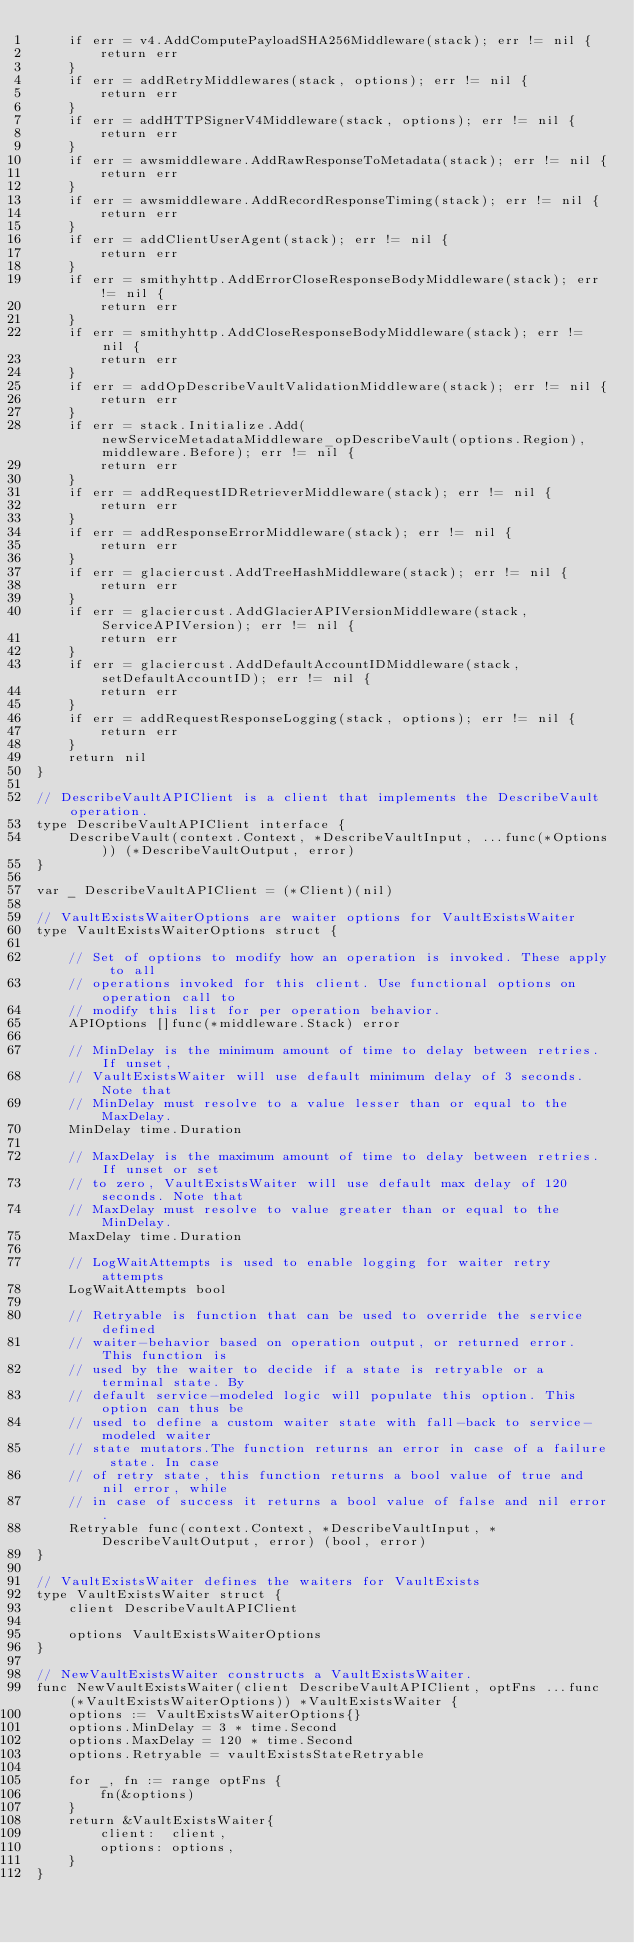<code> <loc_0><loc_0><loc_500><loc_500><_Go_>	if err = v4.AddComputePayloadSHA256Middleware(stack); err != nil {
		return err
	}
	if err = addRetryMiddlewares(stack, options); err != nil {
		return err
	}
	if err = addHTTPSignerV4Middleware(stack, options); err != nil {
		return err
	}
	if err = awsmiddleware.AddRawResponseToMetadata(stack); err != nil {
		return err
	}
	if err = awsmiddleware.AddRecordResponseTiming(stack); err != nil {
		return err
	}
	if err = addClientUserAgent(stack); err != nil {
		return err
	}
	if err = smithyhttp.AddErrorCloseResponseBodyMiddleware(stack); err != nil {
		return err
	}
	if err = smithyhttp.AddCloseResponseBodyMiddleware(stack); err != nil {
		return err
	}
	if err = addOpDescribeVaultValidationMiddleware(stack); err != nil {
		return err
	}
	if err = stack.Initialize.Add(newServiceMetadataMiddleware_opDescribeVault(options.Region), middleware.Before); err != nil {
		return err
	}
	if err = addRequestIDRetrieverMiddleware(stack); err != nil {
		return err
	}
	if err = addResponseErrorMiddleware(stack); err != nil {
		return err
	}
	if err = glaciercust.AddTreeHashMiddleware(stack); err != nil {
		return err
	}
	if err = glaciercust.AddGlacierAPIVersionMiddleware(stack, ServiceAPIVersion); err != nil {
		return err
	}
	if err = glaciercust.AddDefaultAccountIDMiddleware(stack, setDefaultAccountID); err != nil {
		return err
	}
	if err = addRequestResponseLogging(stack, options); err != nil {
		return err
	}
	return nil
}

// DescribeVaultAPIClient is a client that implements the DescribeVault operation.
type DescribeVaultAPIClient interface {
	DescribeVault(context.Context, *DescribeVaultInput, ...func(*Options)) (*DescribeVaultOutput, error)
}

var _ DescribeVaultAPIClient = (*Client)(nil)

// VaultExistsWaiterOptions are waiter options for VaultExistsWaiter
type VaultExistsWaiterOptions struct {

	// Set of options to modify how an operation is invoked. These apply to all
	// operations invoked for this client. Use functional options on operation call to
	// modify this list for per operation behavior.
	APIOptions []func(*middleware.Stack) error

	// MinDelay is the minimum amount of time to delay between retries. If unset,
	// VaultExistsWaiter will use default minimum delay of 3 seconds. Note that
	// MinDelay must resolve to a value lesser than or equal to the MaxDelay.
	MinDelay time.Duration

	// MaxDelay is the maximum amount of time to delay between retries. If unset or set
	// to zero, VaultExistsWaiter will use default max delay of 120 seconds. Note that
	// MaxDelay must resolve to value greater than or equal to the MinDelay.
	MaxDelay time.Duration

	// LogWaitAttempts is used to enable logging for waiter retry attempts
	LogWaitAttempts bool

	// Retryable is function that can be used to override the service defined
	// waiter-behavior based on operation output, or returned error. This function is
	// used by the waiter to decide if a state is retryable or a terminal state. By
	// default service-modeled logic will populate this option. This option can thus be
	// used to define a custom waiter state with fall-back to service-modeled waiter
	// state mutators.The function returns an error in case of a failure state. In case
	// of retry state, this function returns a bool value of true and nil error, while
	// in case of success it returns a bool value of false and nil error.
	Retryable func(context.Context, *DescribeVaultInput, *DescribeVaultOutput, error) (bool, error)
}

// VaultExistsWaiter defines the waiters for VaultExists
type VaultExistsWaiter struct {
	client DescribeVaultAPIClient

	options VaultExistsWaiterOptions
}

// NewVaultExistsWaiter constructs a VaultExistsWaiter.
func NewVaultExistsWaiter(client DescribeVaultAPIClient, optFns ...func(*VaultExistsWaiterOptions)) *VaultExistsWaiter {
	options := VaultExistsWaiterOptions{}
	options.MinDelay = 3 * time.Second
	options.MaxDelay = 120 * time.Second
	options.Retryable = vaultExistsStateRetryable

	for _, fn := range optFns {
		fn(&options)
	}
	return &VaultExistsWaiter{
		client:  client,
		options: options,
	}
}
</code> 